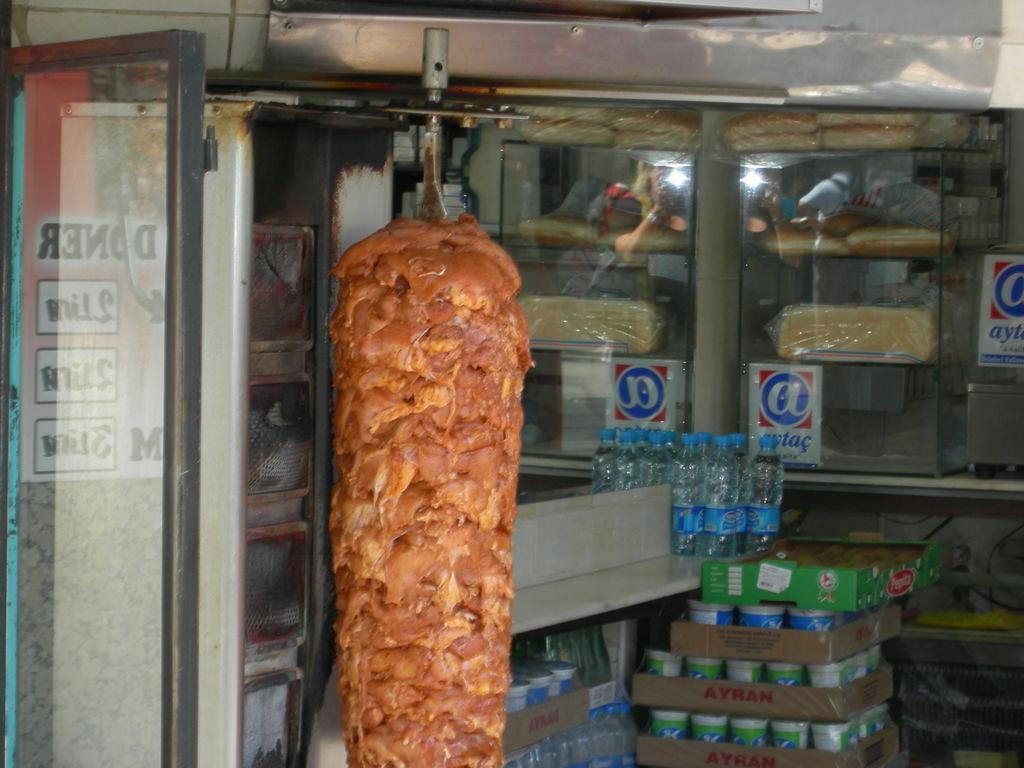Please provide a concise description of this image. In this image I can see a metal object onto which meat is being arranged for shawarma. I can see a glass cupboard in which I can see hot dogs, bread. I can see water bottles and other beverages in cartons. On the left hand side, I can see a glass door on which I can see the reflection of a poster with some text. 